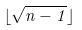<formula> <loc_0><loc_0><loc_500><loc_500>\lfloor \sqrt { n - 1 } \rfloor</formula> 